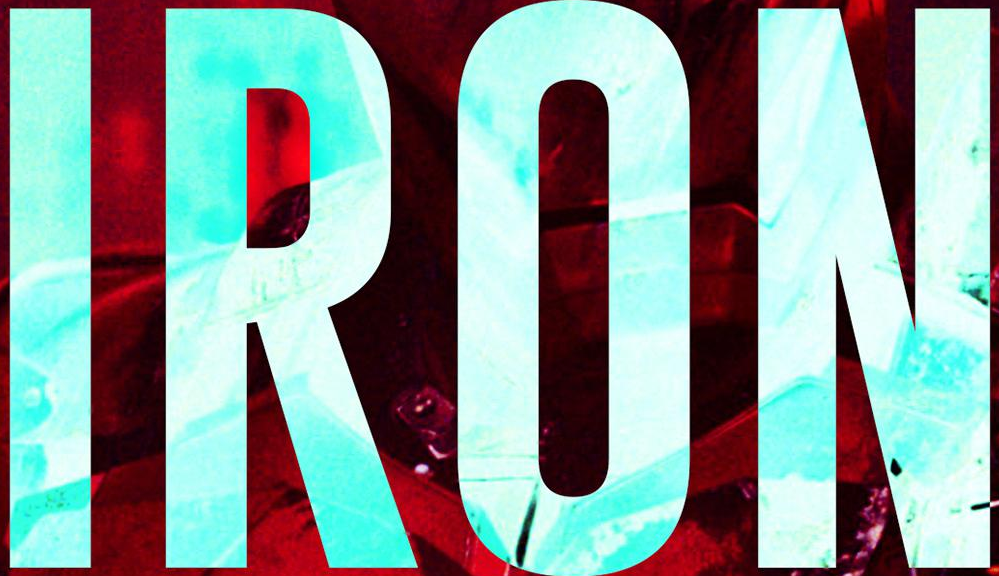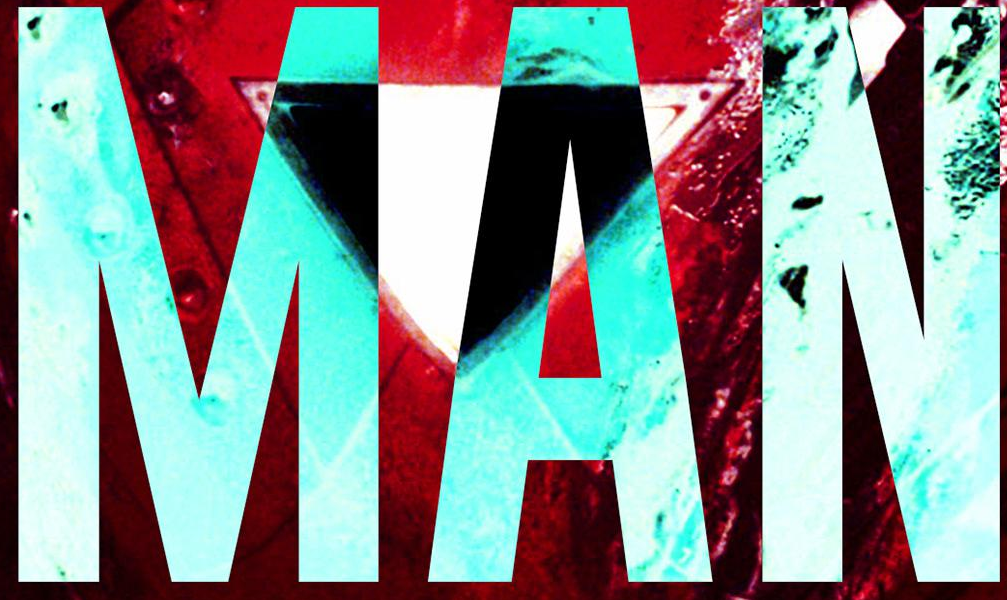What words are shown in these images in order, separated by a semicolon? IRON; MAN 